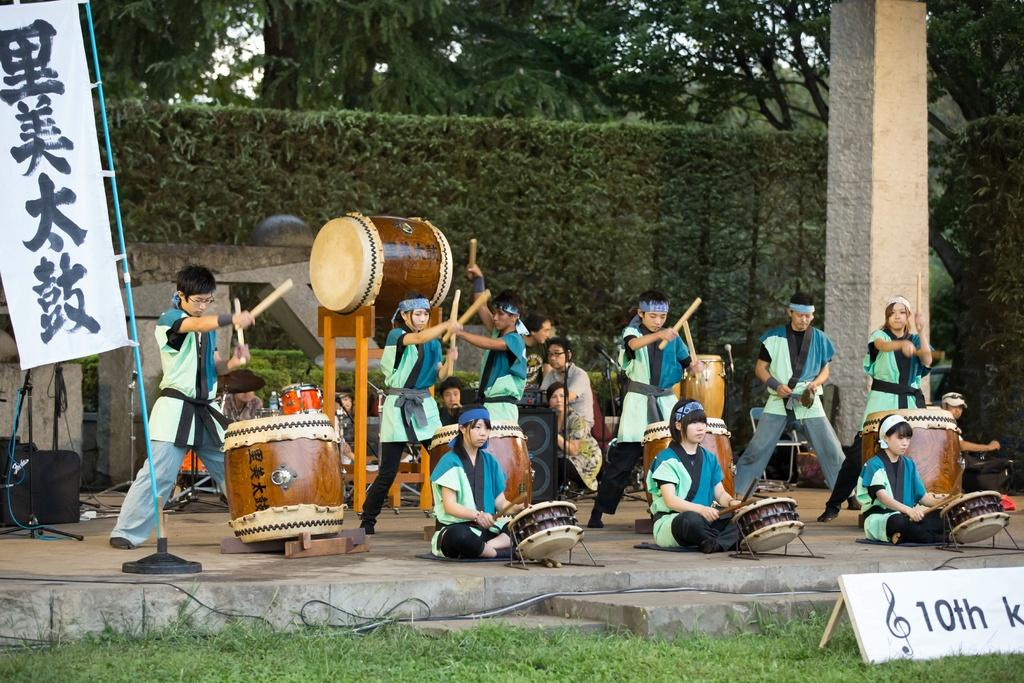How many people are in the image? There is a group of persons in the image. What are the persons in the image doing? The persons are beating drums. What can be seen in the background of the image? There are trees and a pole in the background of the image. Can you see any hands running in the image? There are no hands running in the image; the focus is on the persons beating drums. 